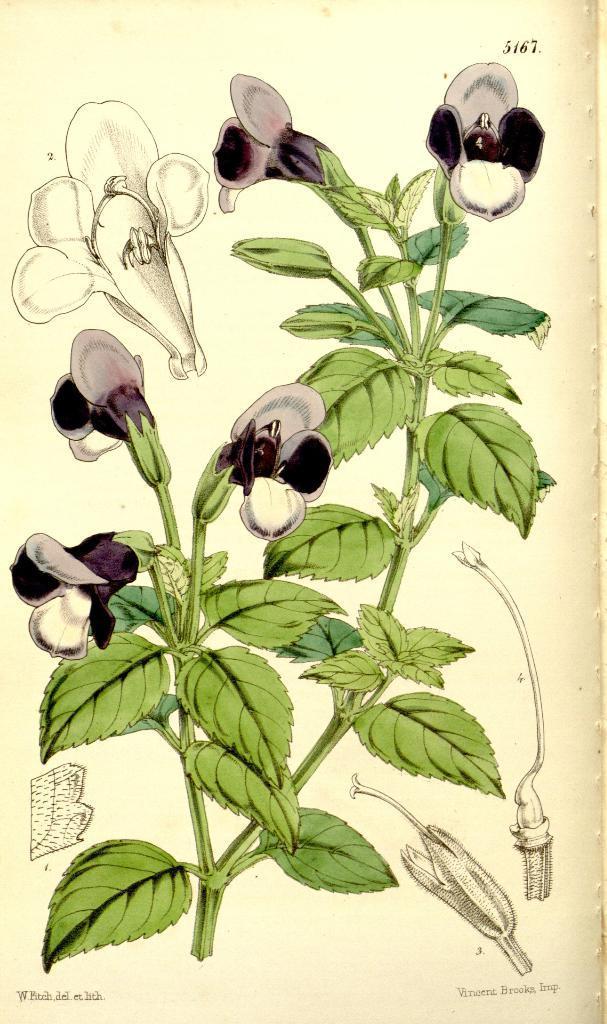Could you give a brief overview of what you see in this image? In the image there is a picture of a flower plant. 